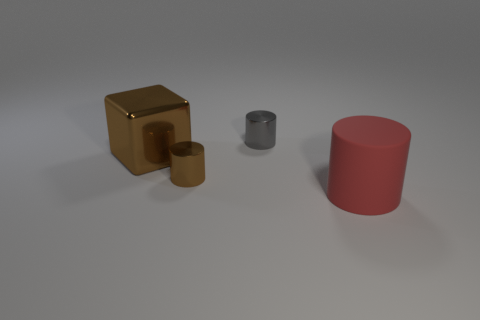What is the shape of the tiny metallic thing that is the same color as the shiny cube?
Your answer should be very brief. Cylinder. What is the size of the shiny thing that is the same color as the block?
Ensure brevity in your answer.  Small. What size is the object in front of the small shiny object that is in front of the big metal object that is in front of the small gray metallic object?
Provide a succinct answer. Large. Does the gray object have the same shape as the thing to the right of the tiny gray metal thing?
Make the answer very short. Yes. What is the large brown thing made of?
Your answer should be very brief. Metal. What number of shiny objects are small yellow spheres or big red cylinders?
Make the answer very short. 0. Are there fewer brown cylinders that are on the left side of the big metallic object than red objects to the left of the large red rubber object?
Your answer should be very brief. No. Is there a shiny cylinder that is left of the large object behind the matte cylinder that is on the right side of the large brown metallic thing?
Your answer should be very brief. No. What material is the cylinder that is the same color as the metallic cube?
Make the answer very short. Metal. There is a brown shiny thing that is to the right of the large block; is it the same shape as the small gray object that is on the right side of the brown cylinder?
Make the answer very short. Yes. 